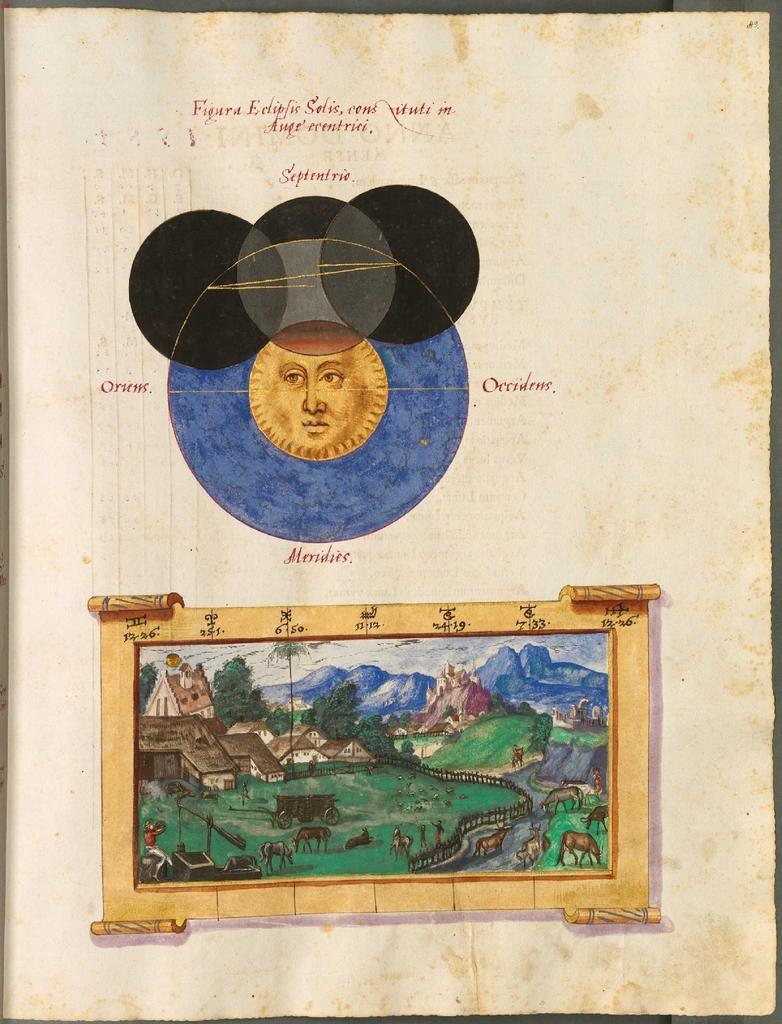How would you summarize this image in a sentence or two? In this image I can see a poster in which I can see a photograph of a village in which I can see the ground, some grass, the railing, few mountains, few buildings, few trees and the sky. I can see a person's face in brown color. 